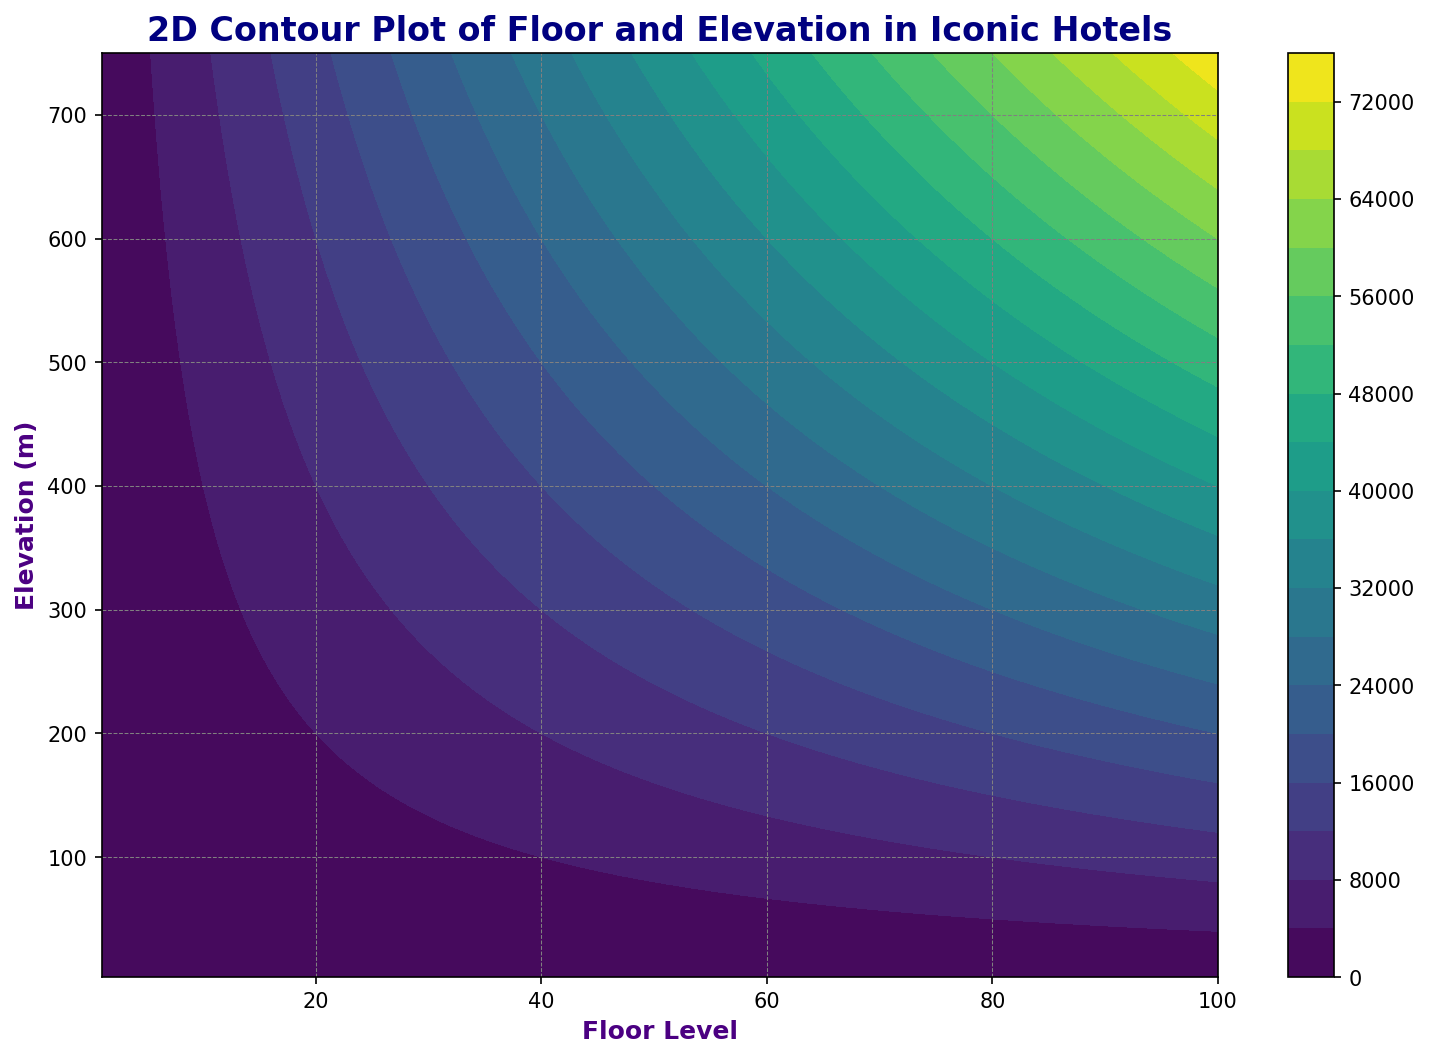What is the lowest visible elevation value in the contour plot? The lowest visible elevation value can be found at the bottom of the y-axis on the plot. It is the minimum data value for elevation.
Answer: 3 What is the highest floor number shown in the plot? The highest floor number is located at the right end of the x-axis on the plot. It is the maximum value from the floor data.
Answer: 100 Which floor corresponds to an elevation of approximately 200 meters? First, locate the elevation of 200 meters on the y-axis, then trace horizontally to find the corresponding floor number on the x-axis where the contour intersects this elevation.
Answer: 27 Compare the elevation at floor 20 with the elevation at floor 40. Which is higher and by how much? Check both elevations for floors 20 (70) and 40 (180) from the y-axis. Subtract the elevation for the lower floor from the higher one. 180 - 70 = 110
Answer: 40 is higher by 110 meters If the elevation increases consistently, what would be the expected floor level at an elevation of 500 meters? Given elevation consistently increases by 10 meters per floor, calculate by dividing 500 by 10 to deduce the floor with that elevation. 500 / 10 = 50
Answer: 50 Describe the color gradient shown in the contour plot. Observe the color transitions vertically. The plot uses a 'viridis' color palette, which smoothly transitions from dark purple to yellow as elevation increases.
Answer: Dark purple to yellow Determine the range of elevation values between floor 10 and floor 20. Find the elevations for floor 10 (30) and floor 20 (70) on the y-axis. The range is the difference between these values. 70 - 30 = 40
Answer: 40 meters At what floor does the elevation first exceed 400 meters? Trace horizontally from the 400-meter mark on the y-axis. The first intersection with a floor number on the x-axis indicates the floor where the elevation first exceeds 400 meters.
Answer: Floor 41 Calculate the average elevation for the first 5 floors. List the elevations of the first 5 floors: 3, 6, 9, 12, and 15. Sum these values and divide by 5. (3 + 6 + 9 + 12 + 15) / 5 = 45 / 5
Answer: 9 meters Explain how the grid style enhances the readability of the data. The plot’s grid lines, styled with gray color and dashed lines, help track horizontal and vertical measurements, making it easier to locate specific elevations and floor levels accurately.
Answer: Enhances readability through clear alignment 